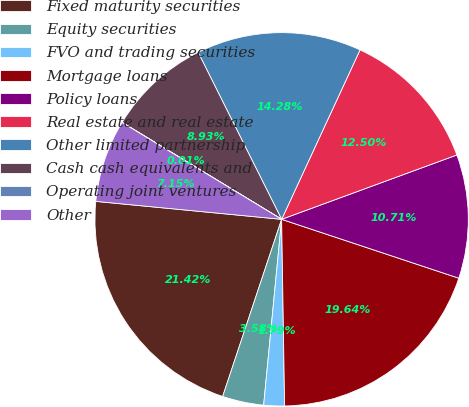Convert chart to OTSL. <chart><loc_0><loc_0><loc_500><loc_500><pie_chart><fcel>Fixed maturity securities<fcel>Equity securities<fcel>FVO and trading securities<fcel>Mortgage loans<fcel>Policy loans<fcel>Real estate and real estate<fcel>Other limited partnership<fcel>Cash cash equivalents and<fcel>Operating joint ventures<fcel>Other<nl><fcel>21.42%<fcel>3.58%<fcel>1.79%<fcel>19.64%<fcel>10.71%<fcel>12.5%<fcel>14.28%<fcel>8.93%<fcel>0.01%<fcel>7.15%<nl></chart> 